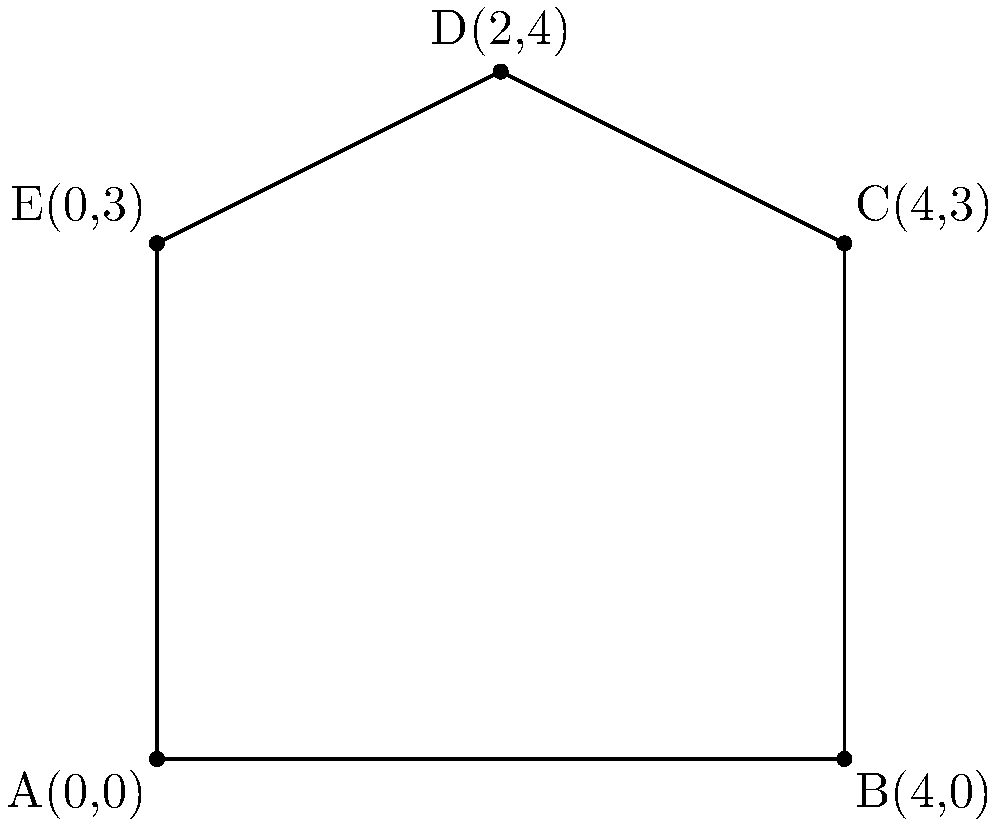In an emergency communication system, the coverage area is represented by a polygon on a coordinate plane. The polygon is defined by the following points: A(0,0), B(4,0), C(4,3), D(2,4), and E(0,3). Calculate the area of this coverage region using the shoelace formula. Round your answer to two decimal places. To calculate the area of the polygon using the shoelace formula, we'll follow these steps:

1) The shoelace formula for a polygon with vertices $(x_1, y_1), (x_2, y_2), ..., (x_n, y_n)$ is:

   Area = $\frac{1}{2}|(x_1y_2 + x_2y_3 + ... + x_ny_1) - (y_1x_2 + y_2x_3 + ... + y_nx_1)|$

2) Let's arrange our points in order:
   A(0,0), B(4,0), C(4,3), D(2,4), E(0,3)

3) Now, let's calculate the two sums:
   
   Sum1 = $(0 \cdot 0) + (4 \cdot 3) + (4 \cdot 4) + (2 \cdot 3) + (0 \cdot 0) = 0 + 12 + 16 + 6 + 0 = 34$
   
   Sum2 = $(0 \cdot 4) + (0 \cdot 4) + (3 \cdot 2) + (4 \cdot 0) + (3 \cdot 0) = 0 + 0 + 6 + 0 + 0 = 6$

4) Subtract Sum2 from Sum1:
   $34 - 6 = 28$

5) Take the absolute value (in this case, it's already positive) and divide by 2:
   $\frac{28}{2} = 14$

Therefore, the area of the polygon is 14 square units.
Answer: 14 square units 